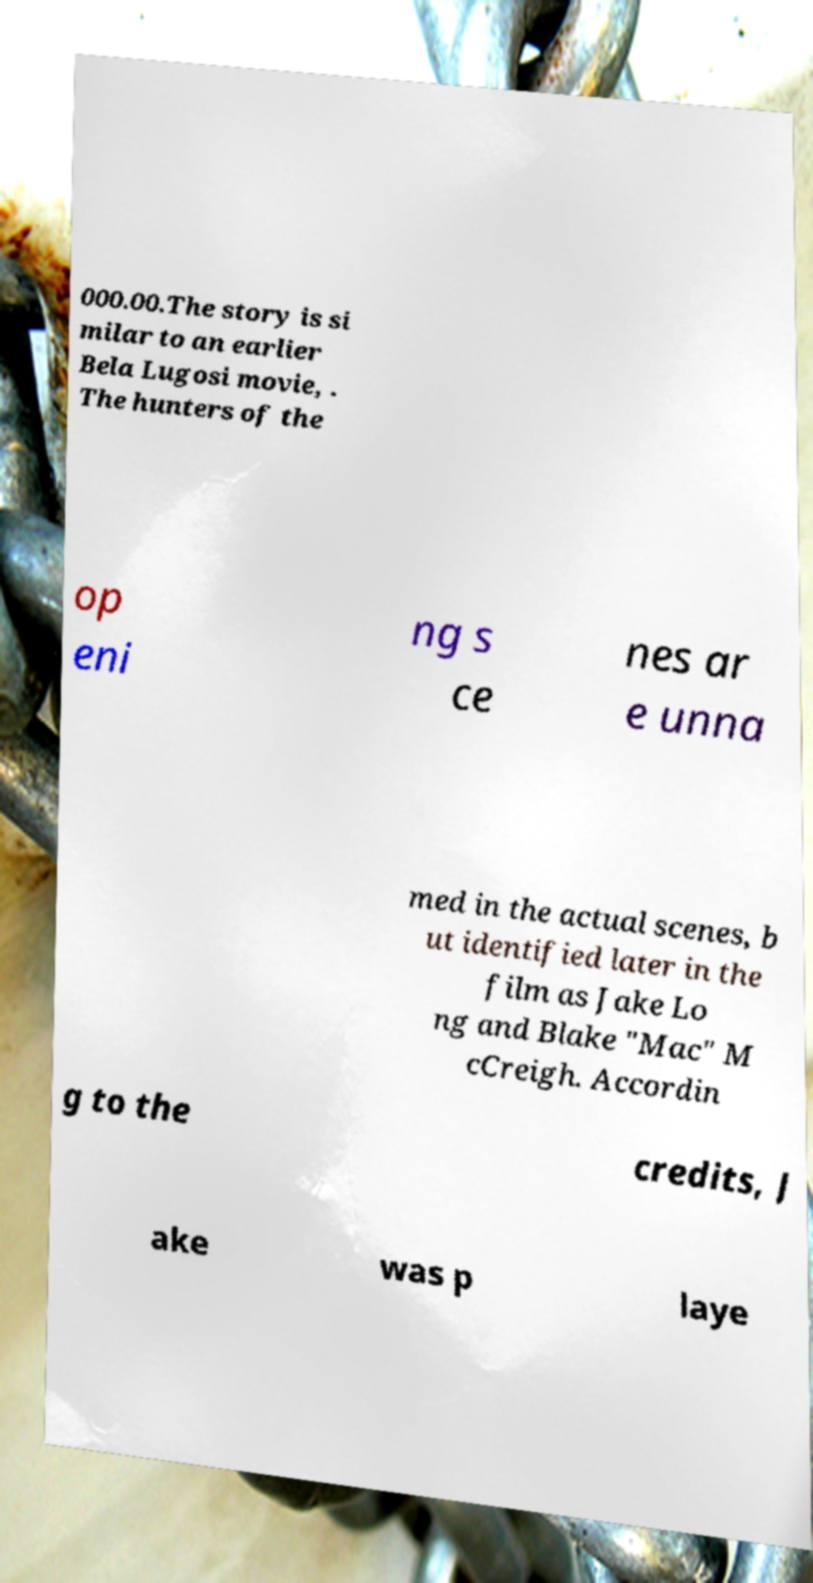Could you assist in decoding the text presented in this image and type it out clearly? 000.00.The story is si milar to an earlier Bela Lugosi movie, . The hunters of the op eni ng s ce nes ar e unna med in the actual scenes, b ut identified later in the film as Jake Lo ng and Blake "Mac" M cCreigh. Accordin g to the credits, J ake was p laye 